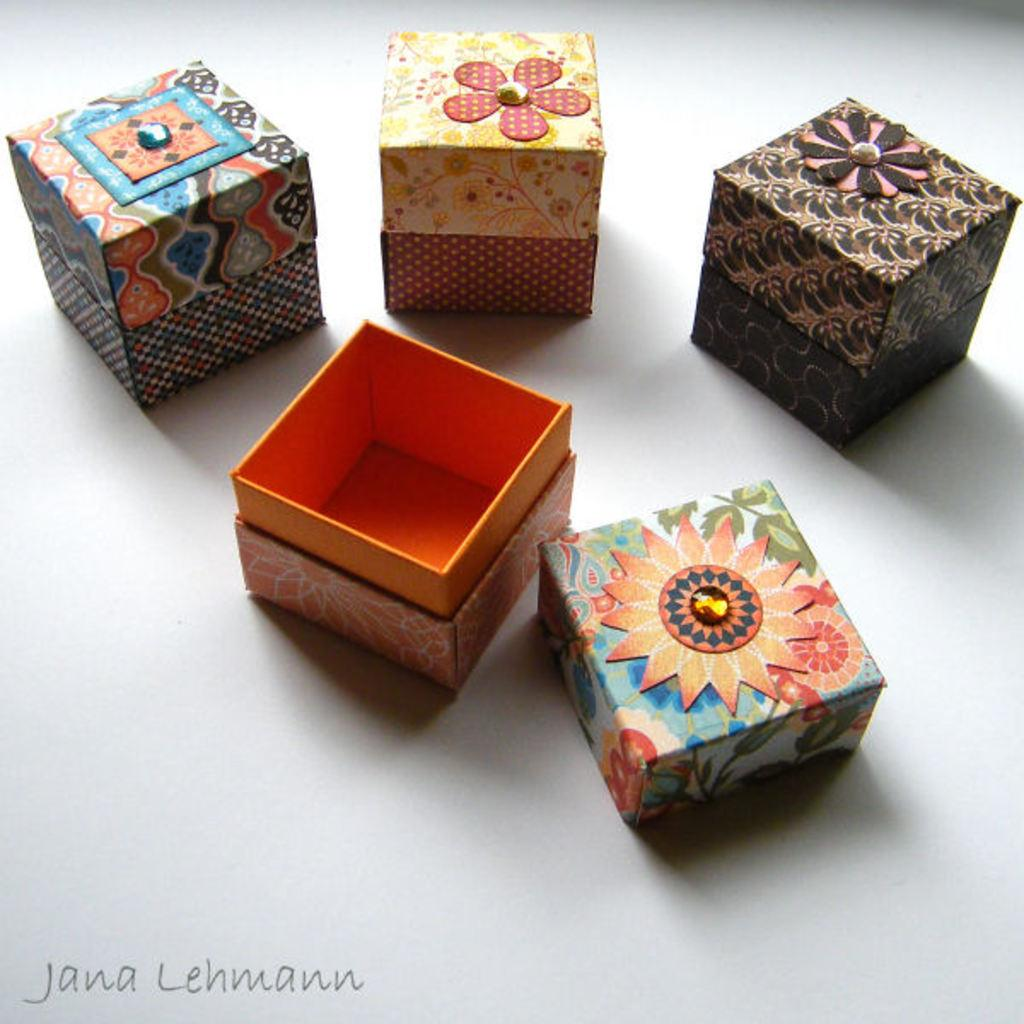<image>
Create a compact narrative representing the image presented. Four boxes in a pohto by Jana Lehmann. 